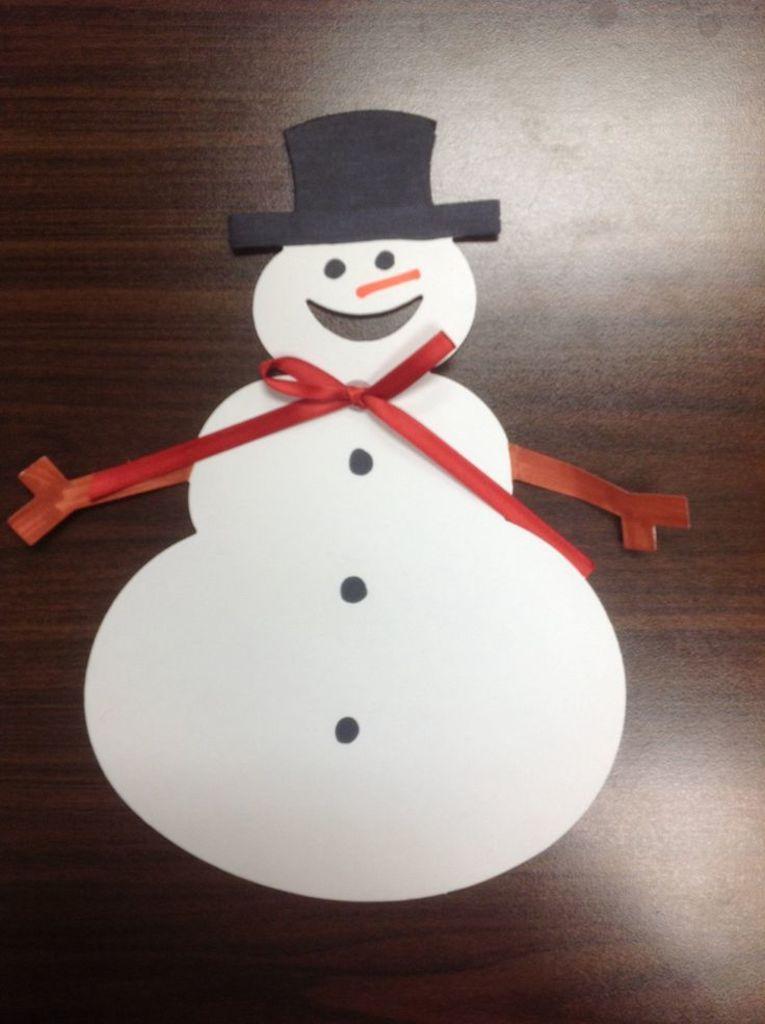Describe this image in one or two sentences. In this image, we can see snow man's craft on a wooden object. Here we can see red color ribbon. 